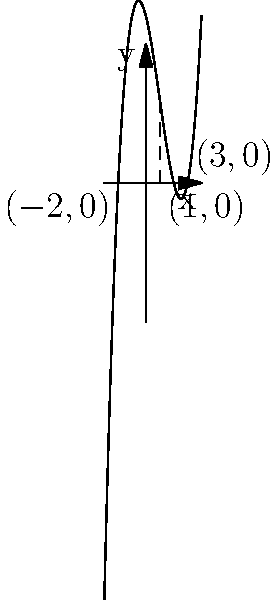The graph above shows a cubic polynomial function. Using only the information provided in the graph and basic algebra, determine the equation of this cubic polynomial in its factored form. Let's approach this step-by-step:

1) From the graph, we can see that the polynomial has three roots: $x = -2$, $x = 1$, and $x = 3$.

2) The general form of a cubic polynomial is $f(x) = a(x-r_1)(x-r_2)(x-r_3)$, where $a$ is a non-zero constant and $r_1$, $r_2$, and $r_3$ are the roots.

3) Substituting our roots, we get:
   $f(x) = a(x+2)(x-1)(x-3)$

4) To find $a$, we need to expand this expression:
   $f(x) = a(x^2+x-2)(x-3)$
   $f(x) = a(x^3-3x^2+x^2-x-2x+6)$
   $f(x) = a(x^3-2x^2-3x+6)$

5) Now, we need to compare this with the standard form of a cubic polynomial:
   $f(x) = ax^3 + bx^2 + cx + d$

6) Looking at the graph, we can see that the coefficient of $x^3$ is positive (the function goes up as $x$ increases). The simplest positive value for $a$ is 1.

7) With $a=1$, our polynomial becomes:
   $f(x) = x^3-2x^2-3x+6$

8) This matches the shape of the graph, so we can conclude that $a=1$.

Therefore, the factored form of the polynomial is $f(x) = (x+2)(x-1)(x-3)$.
Answer: $f(x) = (x+2)(x-1)(x-3)$ 